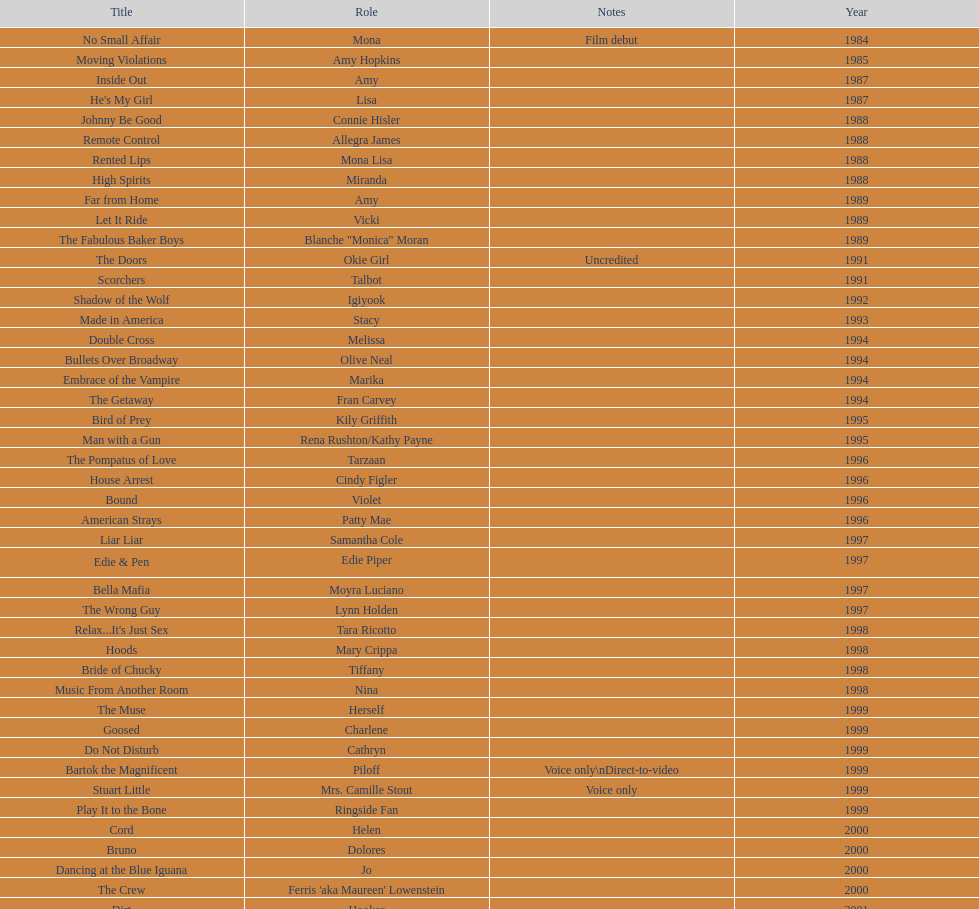How many films does jennifer tilly do a voice over role in? 5. 